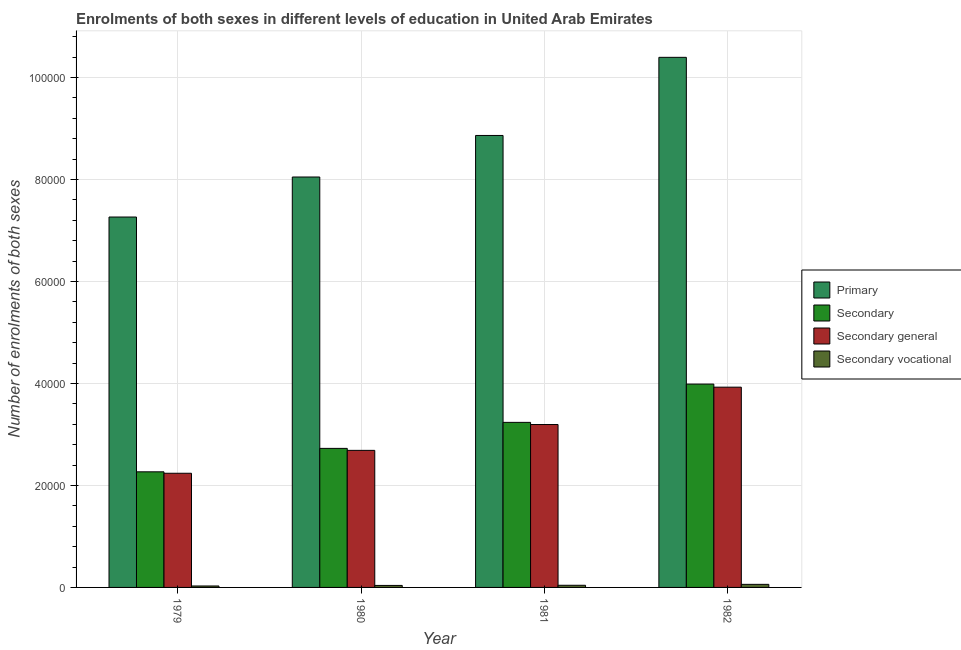How many groups of bars are there?
Provide a short and direct response. 4. Are the number of bars per tick equal to the number of legend labels?
Your answer should be compact. Yes. How many bars are there on the 1st tick from the left?
Ensure brevity in your answer.  4. What is the label of the 2nd group of bars from the left?
Your answer should be compact. 1980. What is the number of enrolments in secondary general education in 1980?
Ensure brevity in your answer.  2.69e+04. Across all years, what is the maximum number of enrolments in secondary education?
Provide a short and direct response. 3.99e+04. Across all years, what is the minimum number of enrolments in primary education?
Your answer should be compact. 7.26e+04. In which year was the number of enrolments in primary education minimum?
Keep it short and to the point. 1979. What is the total number of enrolments in secondary education in the graph?
Your response must be concise. 1.22e+05. What is the difference between the number of enrolments in secondary general education in 1981 and that in 1982?
Make the answer very short. -7326. What is the difference between the number of enrolments in secondary general education in 1979 and the number of enrolments in secondary vocational education in 1980?
Keep it short and to the point. -4488. What is the average number of enrolments in secondary vocational education per year?
Provide a short and direct response. 425. In the year 1980, what is the difference between the number of enrolments in secondary general education and number of enrolments in secondary education?
Provide a succinct answer. 0. In how many years, is the number of enrolments in primary education greater than 88000?
Make the answer very short. 2. What is the ratio of the number of enrolments in secondary education in 1980 to that in 1982?
Your response must be concise. 0.68. What is the difference between the highest and the second highest number of enrolments in primary education?
Ensure brevity in your answer.  1.53e+04. What is the difference between the highest and the lowest number of enrolments in primary education?
Your response must be concise. 3.13e+04. In how many years, is the number of enrolments in secondary vocational education greater than the average number of enrolments in secondary vocational education taken over all years?
Make the answer very short. 1. Is the sum of the number of enrolments in secondary general education in 1979 and 1982 greater than the maximum number of enrolments in secondary vocational education across all years?
Give a very brief answer. Yes. What does the 4th bar from the left in 1982 represents?
Provide a succinct answer. Secondary vocational. What does the 3rd bar from the right in 1979 represents?
Offer a very short reply. Secondary. How many bars are there?
Offer a very short reply. 16. Are all the bars in the graph horizontal?
Give a very brief answer. No. How many years are there in the graph?
Provide a succinct answer. 4. What is the difference between two consecutive major ticks on the Y-axis?
Give a very brief answer. 2.00e+04. Does the graph contain any zero values?
Your answer should be very brief. No. Does the graph contain grids?
Offer a terse response. Yes. Where does the legend appear in the graph?
Give a very brief answer. Center right. How are the legend labels stacked?
Provide a succinct answer. Vertical. What is the title of the graph?
Provide a succinct answer. Enrolments of both sexes in different levels of education in United Arab Emirates. Does "Belgium" appear as one of the legend labels in the graph?
Your answer should be compact. No. What is the label or title of the X-axis?
Keep it short and to the point. Year. What is the label or title of the Y-axis?
Offer a very short reply. Number of enrolments of both sexes. What is the Number of enrolments of both sexes of Primary in 1979?
Make the answer very short. 7.26e+04. What is the Number of enrolments of both sexes of Secondary in 1979?
Offer a very short reply. 2.27e+04. What is the Number of enrolments of both sexes in Secondary general in 1979?
Provide a short and direct response. 2.24e+04. What is the Number of enrolments of both sexes in Secondary vocational in 1979?
Provide a succinct answer. 284. What is the Number of enrolments of both sexes in Primary in 1980?
Offer a terse response. 8.05e+04. What is the Number of enrolments of both sexes of Secondary in 1980?
Provide a succinct answer. 2.73e+04. What is the Number of enrolments of both sexes of Secondary general in 1980?
Offer a very short reply. 2.69e+04. What is the Number of enrolments of both sexes in Secondary vocational in 1980?
Give a very brief answer. 392. What is the Number of enrolments of both sexes of Primary in 1981?
Keep it short and to the point. 8.86e+04. What is the Number of enrolments of both sexes of Secondary in 1981?
Your answer should be compact. 3.24e+04. What is the Number of enrolments of both sexes of Secondary general in 1981?
Provide a succinct answer. 3.19e+04. What is the Number of enrolments of both sexes in Secondary vocational in 1981?
Provide a short and direct response. 422. What is the Number of enrolments of both sexes of Primary in 1982?
Your answer should be very brief. 1.04e+05. What is the Number of enrolments of both sexes in Secondary in 1982?
Provide a short and direct response. 3.99e+04. What is the Number of enrolments of both sexes of Secondary general in 1982?
Offer a very short reply. 3.93e+04. What is the Number of enrolments of both sexes of Secondary vocational in 1982?
Your answer should be compact. 602. Across all years, what is the maximum Number of enrolments of both sexes in Primary?
Your response must be concise. 1.04e+05. Across all years, what is the maximum Number of enrolments of both sexes in Secondary?
Provide a short and direct response. 3.99e+04. Across all years, what is the maximum Number of enrolments of both sexes of Secondary general?
Your answer should be compact. 3.93e+04. Across all years, what is the maximum Number of enrolments of both sexes of Secondary vocational?
Give a very brief answer. 602. Across all years, what is the minimum Number of enrolments of both sexes of Primary?
Your response must be concise. 7.26e+04. Across all years, what is the minimum Number of enrolments of both sexes of Secondary?
Keep it short and to the point. 2.27e+04. Across all years, what is the minimum Number of enrolments of both sexes in Secondary general?
Offer a terse response. 2.24e+04. Across all years, what is the minimum Number of enrolments of both sexes in Secondary vocational?
Your answer should be compact. 284. What is the total Number of enrolments of both sexes in Primary in the graph?
Provide a short and direct response. 3.46e+05. What is the total Number of enrolments of both sexes in Secondary in the graph?
Your answer should be very brief. 1.22e+05. What is the total Number of enrolments of both sexes of Secondary general in the graph?
Provide a succinct answer. 1.20e+05. What is the total Number of enrolments of both sexes of Secondary vocational in the graph?
Provide a succinct answer. 1700. What is the difference between the Number of enrolments of both sexes of Primary in 1979 and that in 1980?
Your answer should be compact. -7843. What is the difference between the Number of enrolments of both sexes of Secondary in 1979 and that in 1980?
Make the answer very short. -4596. What is the difference between the Number of enrolments of both sexes of Secondary general in 1979 and that in 1980?
Offer a terse response. -4488. What is the difference between the Number of enrolments of both sexes in Secondary vocational in 1979 and that in 1980?
Give a very brief answer. -108. What is the difference between the Number of enrolments of both sexes in Primary in 1979 and that in 1981?
Offer a terse response. -1.60e+04. What is the difference between the Number of enrolments of both sexes in Secondary in 1979 and that in 1981?
Your answer should be compact. -9694. What is the difference between the Number of enrolments of both sexes in Secondary general in 1979 and that in 1981?
Offer a very short reply. -9556. What is the difference between the Number of enrolments of both sexes of Secondary vocational in 1979 and that in 1981?
Provide a short and direct response. -138. What is the difference between the Number of enrolments of both sexes of Primary in 1979 and that in 1982?
Ensure brevity in your answer.  -3.13e+04. What is the difference between the Number of enrolments of both sexes of Secondary in 1979 and that in 1982?
Your answer should be compact. -1.72e+04. What is the difference between the Number of enrolments of both sexes of Secondary general in 1979 and that in 1982?
Provide a short and direct response. -1.69e+04. What is the difference between the Number of enrolments of both sexes in Secondary vocational in 1979 and that in 1982?
Provide a succinct answer. -318. What is the difference between the Number of enrolments of both sexes of Primary in 1980 and that in 1981?
Your answer should be very brief. -8147. What is the difference between the Number of enrolments of both sexes in Secondary in 1980 and that in 1981?
Your response must be concise. -5098. What is the difference between the Number of enrolments of both sexes of Secondary general in 1980 and that in 1981?
Provide a short and direct response. -5068. What is the difference between the Number of enrolments of both sexes of Primary in 1980 and that in 1982?
Offer a very short reply. -2.35e+04. What is the difference between the Number of enrolments of both sexes in Secondary in 1980 and that in 1982?
Keep it short and to the point. -1.26e+04. What is the difference between the Number of enrolments of both sexes of Secondary general in 1980 and that in 1982?
Offer a terse response. -1.24e+04. What is the difference between the Number of enrolments of both sexes of Secondary vocational in 1980 and that in 1982?
Your response must be concise. -210. What is the difference between the Number of enrolments of both sexes in Primary in 1981 and that in 1982?
Offer a terse response. -1.53e+04. What is the difference between the Number of enrolments of both sexes in Secondary in 1981 and that in 1982?
Offer a very short reply. -7506. What is the difference between the Number of enrolments of both sexes in Secondary general in 1981 and that in 1982?
Give a very brief answer. -7326. What is the difference between the Number of enrolments of both sexes of Secondary vocational in 1981 and that in 1982?
Offer a terse response. -180. What is the difference between the Number of enrolments of both sexes in Primary in 1979 and the Number of enrolments of both sexes in Secondary in 1980?
Keep it short and to the point. 4.54e+04. What is the difference between the Number of enrolments of both sexes in Primary in 1979 and the Number of enrolments of both sexes in Secondary general in 1980?
Your answer should be very brief. 4.58e+04. What is the difference between the Number of enrolments of both sexes of Primary in 1979 and the Number of enrolments of both sexes of Secondary vocational in 1980?
Provide a succinct answer. 7.22e+04. What is the difference between the Number of enrolments of both sexes in Secondary in 1979 and the Number of enrolments of both sexes in Secondary general in 1980?
Ensure brevity in your answer.  -4204. What is the difference between the Number of enrolments of both sexes in Secondary in 1979 and the Number of enrolments of both sexes in Secondary vocational in 1980?
Your response must be concise. 2.23e+04. What is the difference between the Number of enrolments of both sexes in Secondary general in 1979 and the Number of enrolments of both sexes in Secondary vocational in 1980?
Your answer should be very brief. 2.20e+04. What is the difference between the Number of enrolments of both sexes of Primary in 1979 and the Number of enrolments of both sexes of Secondary in 1981?
Your response must be concise. 4.03e+04. What is the difference between the Number of enrolments of both sexes in Primary in 1979 and the Number of enrolments of both sexes in Secondary general in 1981?
Provide a short and direct response. 4.07e+04. What is the difference between the Number of enrolments of both sexes of Primary in 1979 and the Number of enrolments of both sexes of Secondary vocational in 1981?
Your response must be concise. 7.22e+04. What is the difference between the Number of enrolments of both sexes in Secondary in 1979 and the Number of enrolments of both sexes in Secondary general in 1981?
Your answer should be very brief. -9272. What is the difference between the Number of enrolments of both sexes in Secondary in 1979 and the Number of enrolments of both sexes in Secondary vocational in 1981?
Your answer should be compact. 2.22e+04. What is the difference between the Number of enrolments of both sexes in Secondary general in 1979 and the Number of enrolments of both sexes in Secondary vocational in 1981?
Your answer should be very brief. 2.20e+04. What is the difference between the Number of enrolments of both sexes of Primary in 1979 and the Number of enrolments of both sexes of Secondary in 1982?
Your answer should be compact. 3.28e+04. What is the difference between the Number of enrolments of both sexes of Primary in 1979 and the Number of enrolments of both sexes of Secondary general in 1982?
Ensure brevity in your answer.  3.34e+04. What is the difference between the Number of enrolments of both sexes of Primary in 1979 and the Number of enrolments of both sexes of Secondary vocational in 1982?
Make the answer very short. 7.20e+04. What is the difference between the Number of enrolments of both sexes of Secondary in 1979 and the Number of enrolments of both sexes of Secondary general in 1982?
Keep it short and to the point. -1.66e+04. What is the difference between the Number of enrolments of both sexes in Secondary in 1979 and the Number of enrolments of both sexes in Secondary vocational in 1982?
Your response must be concise. 2.21e+04. What is the difference between the Number of enrolments of both sexes of Secondary general in 1979 and the Number of enrolments of both sexes of Secondary vocational in 1982?
Your answer should be very brief. 2.18e+04. What is the difference between the Number of enrolments of both sexes of Primary in 1980 and the Number of enrolments of both sexes of Secondary in 1981?
Offer a terse response. 4.81e+04. What is the difference between the Number of enrolments of both sexes in Primary in 1980 and the Number of enrolments of both sexes in Secondary general in 1981?
Offer a very short reply. 4.85e+04. What is the difference between the Number of enrolments of both sexes in Primary in 1980 and the Number of enrolments of both sexes in Secondary vocational in 1981?
Ensure brevity in your answer.  8.00e+04. What is the difference between the Number of enrolments of both sexes in Secondary in 1980 and the Number of enrolments of both sexes in Secondary general in 1981?
Ensure brevity in your answer.  -4676. What is the difference between the Number of enrolments of both sexes of Secondary in 1980 and the Number of enrolments of both sexes of Secondary vocational in 1981?
Keep it short and to the point. 2.68e+04. What is the difference between the Number of enrolments of both sexes of Secondary general in 1980 and the Number of enrolments of both sexes of Secondary vocational in 1981?
Make the answer very short. 2.64e+04. What is the difference between the Number of enrolments of both sexes in Primary in 1980 and the Number of enrolments of both sexes in Secondary in 1982?
Keep it short and to the point. 4.06e+04. What is the difference between the Number of enrolments of both sexes in Primary in 1980 and the Number of enrolments of both sexes in Secondary general in 1982?
Make the answer very short. 4.12e+04. What is the difference between the Number of enrolments of both sexes in Primary in 1980 and the Number of enrolments of both sexes in Secondary vocational in 1982?
Provide a succinct answer. 7.99e+04. What is the difference between the Number of enrolments of both sexes of Secondary in 1980 and the Number of enrolments of both sexes of Secondary general in 1982?
Your response must be concise. -1.20e+04. What is the difference between the Number of enrolments of both sexes of Secondary in 1980 and the Number of enrolments of both sexes of Secondary vocational in 1982?
Make the answer very short. 2.67e+04. What is the difference between the Number of enrolments of both sexes in Secondary general in 1980 and the Number of enrolments of both sexes in Secondary vocational in 1982?
Provide a short and direct response. 2.63e+04. What is the difference between the Number of enrolments of both sexes of Primary in 1981 and the Number of enrolments of both sexes of Secondary in 1982?
Your answer should be compact. 4.87e+04. What is the difference between the Number of enrolments of both sexes of Primary in 1981 and the Number of enrolments of both sexes of Secondary general in 1982?
Make the answer very short. 4.94e+04. What is the difference between the Number of enrolments of both sexes of Primary in 1981 and the Number of enrolments of both sexes of Secondary vocational in 1982?
Offer a terse response. 8.80e+04. What is the difference between the Number of enrolments of both sexes of Secondary in 1981 and the Number of enrolments of both sexes of Secondary general in 1982?
Offer a terse response. -6904. What is the difference between the Number of enrolments of both sexes in Secondary in 1981 and the Number of enrolments of both sexes in Secondary vocational in 1982?
Ensure brevity in your answer.  3.18e+04. What is the difference between the Number of enrolments of both sexes of Secondary general in 1981 and the Number of enrolments of both sexes of Secondary vocational in 1982?
Offer a very short reply. 3.13e+04. What is the average Number of enrolments of both sexes of Primary per year?
Your answer should be very brief. 8.64e+04. What is the average Number of enrolments of both sexes in Secondary per year?
Provide a succinct answer. 3.05e+04. What is the average Number of enrolments of both sexes in Secondary general per year?
Keep it short and to the point. 3.01e+04. What is the average Number of enrolments of both sexes in Secondary vocational per year?
Offer a very short reply. 425. In the year 1979, what is the difference between the Number of enrolments of both sexes in Primary and Number of enrolments of both sexes in Secondary?
Your response must be concise. 5.00e+04. In the year 1979, what is the difference between the Number of enrolments of both sexes in Primary and Number of enrolments of both sexes in Secondary general?
Offer a terse response. 5.02e+04. In the year 1979, what is the difference between the Number of enrolments of both sexes of Primary and Number of enrolments of both sexes of Secondary vocational?
Offer a very short reply. 7.23e+04. In the year 1979, what is the difference between the Number of enrolments of both sexes in Secondary and Number of enrolments of both sexes in Secondary general?
Ensure brevity in your answer.  284. In the year 1979, what is the difference between the Number of enrolments of both sexes in Secondary and Number of enrolments of both sexes in Secondary vocational?
Give a very brief answer. 2.24e+04. In the year 1979, what is the difference between the Number of enrolments of both sexes in Secondary general and Number of enrolments of both sexes in Secondary vocational?
Your answer should be compact. 2.21e+04. In the year 1980, what is the difference between the Number of enrolments of both sexes of Primary and Number of enrolments of both sexes of Secondary?
Your answer should be very brief. 5.32e+04. In the year 1980, what is the difference between the Number of enrolments of both sexes in Primary and Number of enrolments of both sexes in Secondary general?
Your answer should be very brief. 5.36e+04. In the year 1980, what is the difference between the Number of enrolments of both sexes in Primary and Number of enrolments of both sexes in Secondary vocational?
Provide a succinct answer. 8.01e+04. In the year 1980, what is the difference between the Number of enrolments of both sexes in Secondary and Number of enrolments of both sexes in Secondary general?
Your answer should be compact. 392. In the year 1980, what is the difference between the Number of enrolments of both sexes of Secondary and Number of enrolments of both sexes of Secondary vocational?
Keep it short and to the point. 2.69e+04. In the year 1980, what is the difference between the Number of enrolments of both sexes in Secondary general and Number of enrolments of both sexes in Secondary vocational?
Keep it short and to the point. 2.65e+04. In the year 1981, what is the difference between the Number of enrolments of both sexes in Primary and Number of enrolments of both sexes in Secondary?
Your answer should be very brief. 5.63e+04. In the year 1981, what is the difference between the Number of enrolments of both sexes in Primary and Number of enrolments of both sexes in Secondary general?
Provide a succinct answer. 5.67e+04. In the year 1981, what is the difference between the Number of enrolments of both sexes of Primary and Number of enrolments of both sexes of Secondary vocational?
Provide a short and direct response. 8.82e+04. In the year 1981, what is the difference between the Number of enrolments of both sexes in Secondary and Number of enrolments of both sexes in Secondary general?
Offer a terse response. 422. In the year 1981, what is the difference between the Number of enrolments of both sexes in Secondary and Number of enrolments of both sexes in Secondary vocational?
Your response must be concise. 3.19e+04. In the year 1981, what is the difference between the Number of enrolments of both sexes in Secondary general and Number of enrolments of both sexes in Secondary vocational?
Your answer should be very brief. 3.15e+04. In the year 1982, what is the difference between the Number of enrolments of both sexes of Primary and Number of enrolments of both sexes of Secondary?
Ensure brevity in your answer.  6.41e+04. In the year 1982, what is the difference between the Number of enrolments of both sexes of Primary and Number of enrolments of both sexes of Secondary general?
Provide a short and direct response. 6.47e+04. In the year 1982, what is the difference between the Number of enrolments of both sexes in Primary and Number of enrolments of both sexes in Secondary vocational?
Ensure brevity in your answer.  1.03e+05. In the year 1982, what is the difference between the Number of enrolments of both sexes of Secondary and Number of enrolments of both sexes of Secondary general?
Offer a very short reply. 602. In the year 1982, what is the difference between the Number of enrolments of both sexes in Secondary and Number of enrolments of both sexes in Secondary vocational?
Provide a succinct answer. 3.93e+04. In the year 1982, what is the difference between the Number of enrolments of both sexes of Secondary general and Number of enrolments of both sexes of Secondary vocational?
Provide a succinct answer. 3.87e+04. What is the ratio of the Number of enrolments of both sexes in Primary in 1979 to that in 1980?
Offer a terse response. 0.9. What is the ratio of the Number of enrolments of both sexes in Secondary in 1979 to that in 1980?
Offer a very short reply. 0.83. What is the ratio of the Number of enrolments of both sexes in Secondary general in 1979 to that in 1980?
Your answer should be compact. 0.83. What is the ratio of the Number of enrolments of both sexes of Secondary vocational in 1979 to that in 1980?
Your answer should be compact. 0.72. What is the ratio of the Number of enrolments of both sexes of Primary in 1979 to that in 1981?
Your response must be concise. 0.82. What is the ratio of the Number of enrolments of both sexes of Secondary in 1979 to that in 1981?
Give a very brief answer. 0.7. What is the ratio of the Number of enrolments of both sexes in Secondary general in 1979 to that in 1981?
Your answer should be very brief. 0.7. What is the ratio of the Number of enrolments of both sexes of Secondary vocational in 1979 to that in 1981?
Offer a terse response. 0.67. What is the ratio of the Number of enrolments of both sexes in Primary in 1979 to that in 1982?
Offer a very short reply. 0.7. What is the ratio of the Number of enrolments of both sexes in Secondary in 1979 to that in 1982?
Offer a very short reply. 0.57. What is the ratio of the Number of enrolments of both sexes in Secondary general in 1979 to that in 1982?
Ensure brevity in your answer.  0.57. What is the ratio of the Number of enrolments of both sexes of Secondary vocational in 1979 to that in 1982?
Offer a very short reply. 0.47. What is the ratio of the Number of enrolments of both sexes in Primary in 1980 to that in 1981?
Give a very brief answer. 0.91. What is the ratio of the Number of enrolments of both sexes in Secondary in 1980 to that in 1981?
Provide a short and direct response. 0.84. What is the ratio of the Number of enrolments of both sexes in Secondary general in 1980 to that in 1981?
Provide a succinct answer. 0.84. What is the ratio of the Number of enrolments of both sexes of Secondary vocational in 1980 to that in 1981?
Your answer should be compact. 0.93. What is the ratio of the Number of enrolments of both sexes in Primary in 1980 to that in 1982?
Offer a very short reply. 0.77. What is the ratio of the Number of enrolments of both sexes of Secondary in 1980 to that in 1982?
Make the answer very short. 0.68. What is the ratio of the Number of enrolments of both sexes of Secondary general in 1980 to that in 1982?
Your answer should be compact. 0.68. What is the ratio of the Number of enrolments of both sexes in Secondary vocational in 1980 to that in 1982?
Ensure brevity in your answer.  0.65. What is the ratio of the Number of enrolments of both sexes in Primary in 1981 to that in 1982?
Ensure brevity in your answer.  0.85. What is the ratio of the Number of enrolments of both sexes in Secondary in 1981 to that in 1982?
Ensure brevity in your answer.  0.81. What is the ratio of the Number of enrolments of both sexes in Secondary general in 1981 to that in 1982?
Give a very brief answer. 0.81. What is the ratio of the Number of enrolments of both sexes in Secondary vocational in 1981 to that in 1982?
Ensure brevity in your answer.  0.7. What is the difference between the highest and the second highest Number of enrolments of both sexes in Primary?
Make the answer very short. 1.53e+04. What is the difference between the highest and the second highest Number of enrolments of both sexes of Secondary?
Your response must be concise. 7506. What is the difference between the highest and the second highest Number of enrolments of both sexes of Secondary general?
Offer a terse response. 7326. What is the difference between the highest and the second highest Number of enrolments of both sexes of Secondary vocational?
Your answer should be very brief. 180. What is the difference between the highest and the lowest Number of enrolments of both sexes in Primary?
Your response must be concise. 3.13e+04. What is the difference between the highest and the lowest Number of enrolments of both sexes in Secondary?
Your response must be concise. 1.72e+04. What is the difference between the highest and the lowest Number of enrolments of both sexes of Secondary general?
Your answer should be very brief. 1.69e+04. What is the difference between the highest and the lowest Number of enrolments of both sexes in Secondary vocational?
Offer a very short reply. 318. 